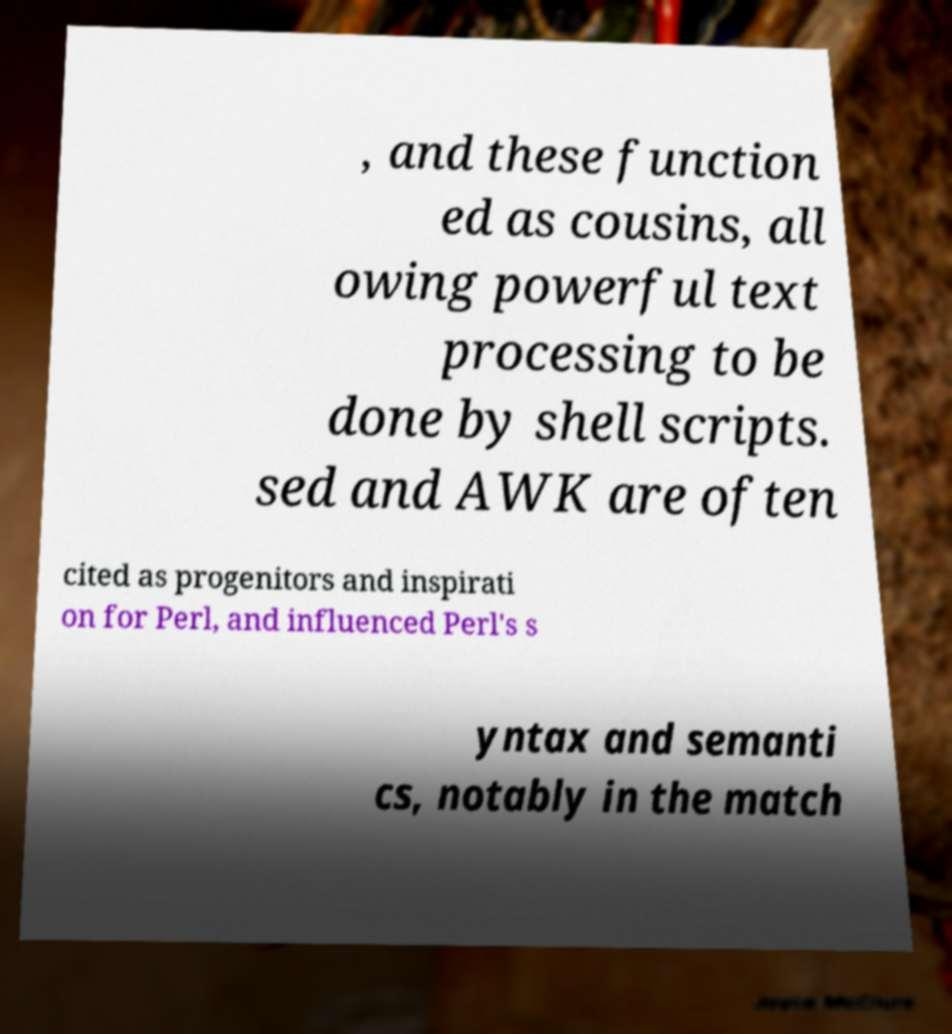Could you extract and type out the text from this image? , and these function ed as cousins, all owing powerful text processing to be done by shell scripts. sed and AWK are often cited as progenitors and inspirati on for Perl, and influenced Perl's s yntax and semanti cs, notably in the match 